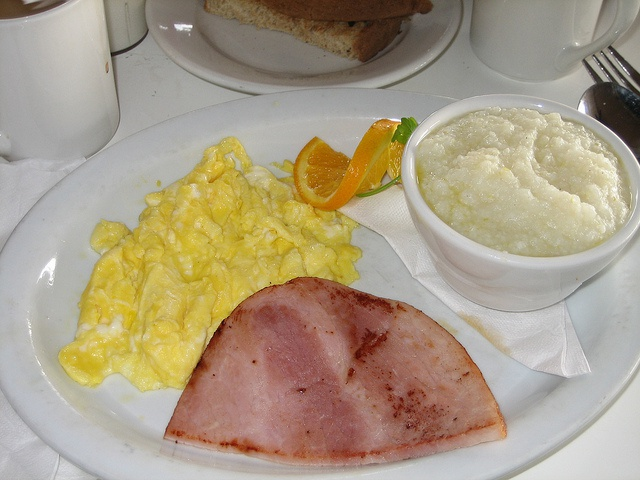Describe the objects in this image and their specific colors. I can see dining table in darkgray, brown, lightgray, tan, and gray tones, bowl in maroon, darkgray, beige, tan, and lightgray tones, cup in maroon, darkgray, and lightgray tones, cup in maroon, darkgray, and gray tones, and sandwich in maroon, black, and gray tones in this image. 